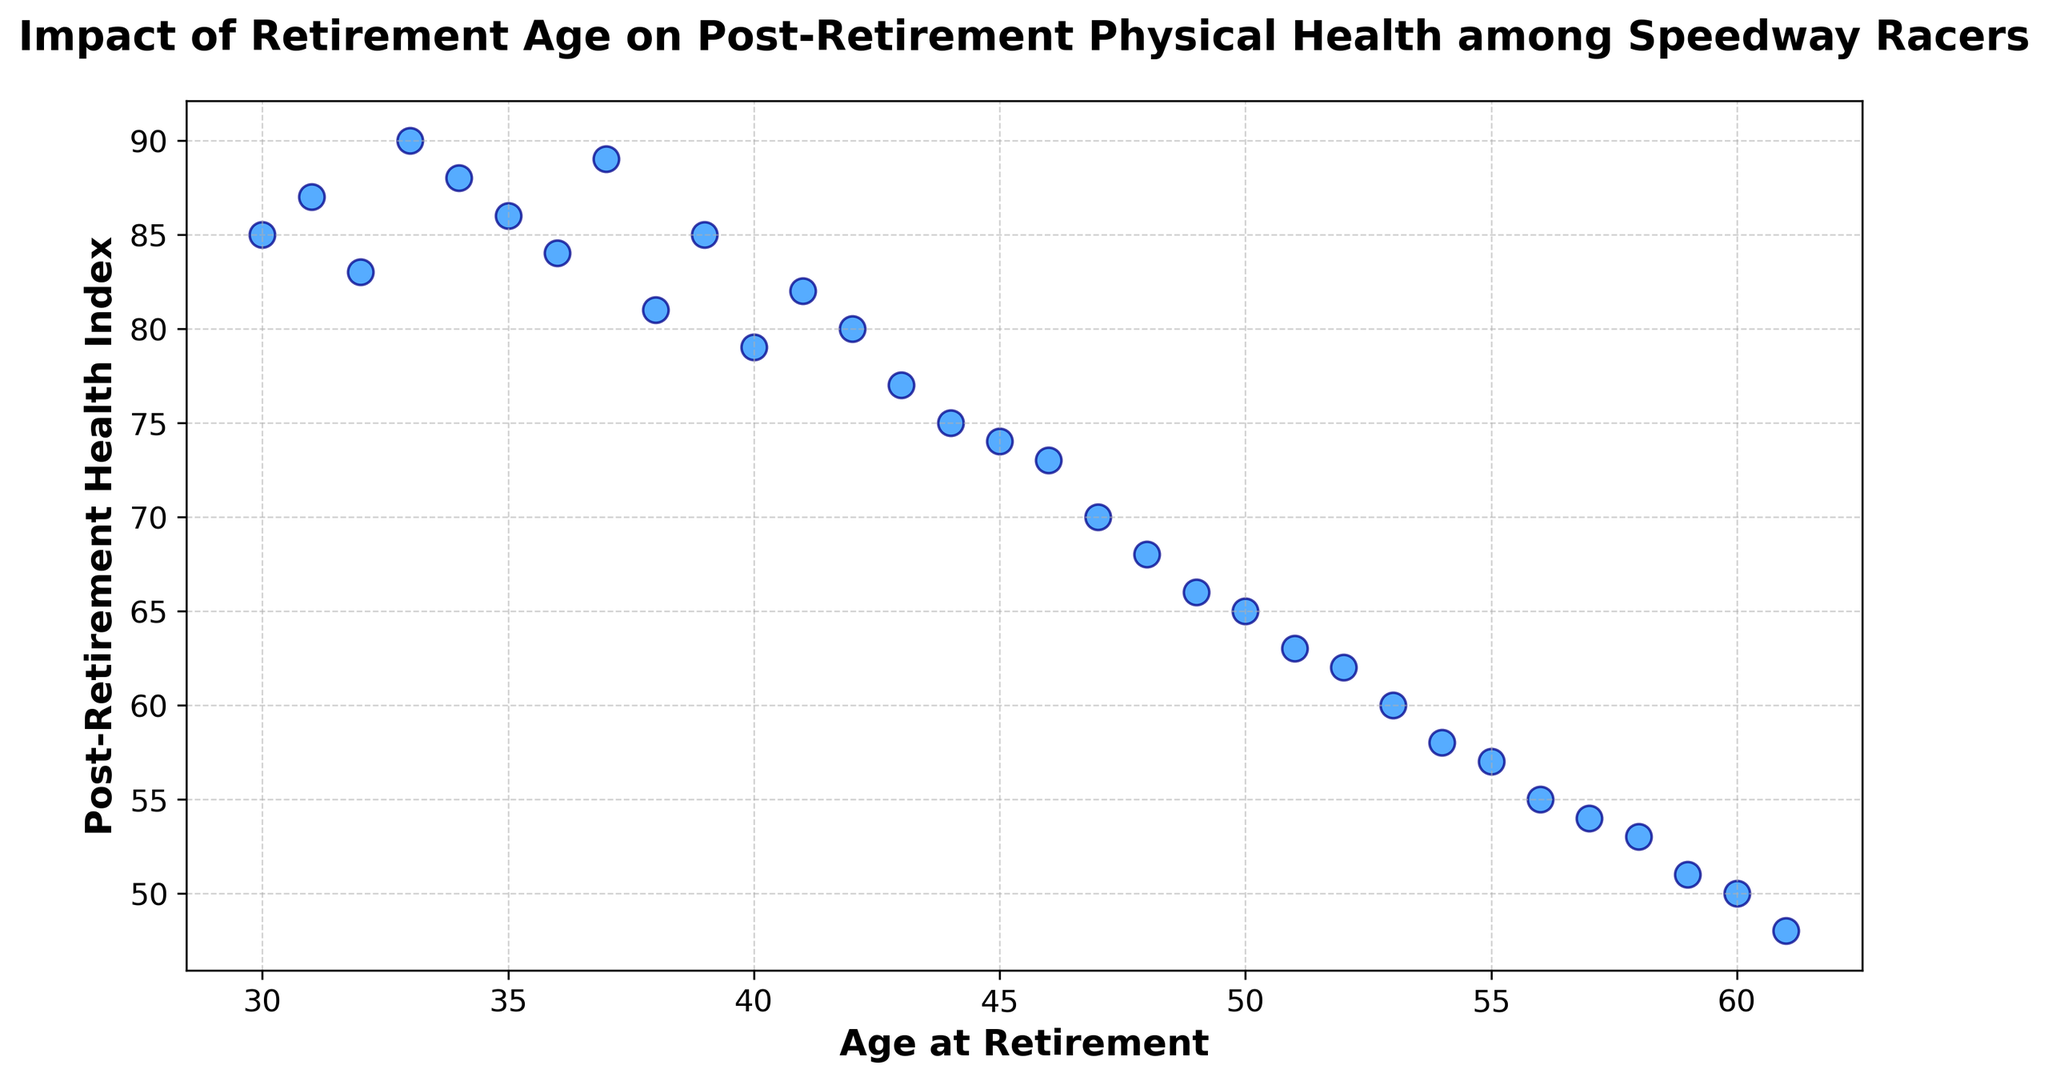What is the overall trend in the post-retirement health index as age at retirement increases? The overall trend can be observed by looking at how the data points are distributed. As the age at retirement increases, the post-retirement health index tends to decrease. This suggests that retiring later might be associated with poorer post-retirement health.
Answer: The health index decreases as age increases Which age group has the highest post-retirement health index? By looking at the data points, the highest post-retirement health index appears around the age of 33.
Answer: Age 33 At what age do we start to see a significant decline in the post-retirement health index below 80? By looking at the scatter plot, data points below a health index of 80 start to appear around the age of 40 and continue to decline afterwards.
Answer: Age 40 How many racers have a post-retirement health index above 70 but below 80? Examine the scatter plot for data points where the post-retirement health index is between 70 and 80. These points occur from ages 42 to 46.
Answer: Five racers Which age has the lowest post-retirement health index and what is its value? Identify the lowest data point in the scatter plot. The age at which the lowest health index occurs is 61, with a value of 48.
Answer: Age 61, Health Index 48 Compare the post-retirement health index of racers who retired at age 35 and age 45. Which is higher? Find and compare the data points for ages 35 and 45. The health index at age 35 is 86, while at age 45 it is 74.
Answer: Age 35 What is the average post-retirement health index for racers who retired between the ages of 50 and 55? Sum the health indices for ages 50, 51, 52, 53, 54, and 55 and divide by the number of data points (6). (65 + 63 + 62 + 60 + 58 + 57) / 6 = 365 / 6 = 60.83
Answer: 60.83 What is the difference in the post-retirement health index between the youngest and oldest racers in the data? The youngest racer is 30 with a health index of 85, and the oldest is 61 with a health index of 48. The difference is 85 - 48 = 37.
Answer: 37 How does the scatter plot visually represent the range of ages? The scatter plot represents the range of ages from 30 to 61 on the x-axis, with each point showing the age at retirement and corresponding health index. Younger ages are on the left and older ages are on the right.
Answer: Age range 30-61 